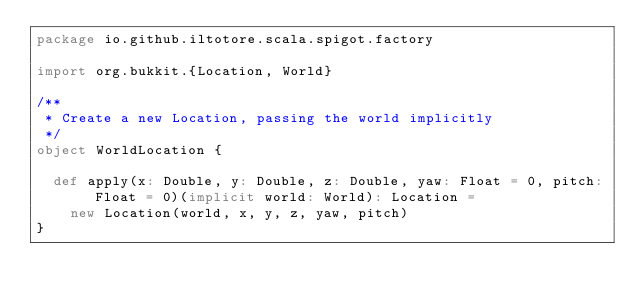<code> <loc_0><loc_0><loc_500><loc_500><_Scala_>package io.github.iltotore.scala.spigot.factory

import org.bukkit.{Location, World}

/**
 * Create a new Location, passing the world implicitly
 */
object WorldLocation {

  def apply(x: Double, y: Double, z: Double, yaw: Float = 0, pitch: Float = 0)(implicit world: World): Location =
    new Location(world, x, y, z, yaw, pitch)
}
</code> 